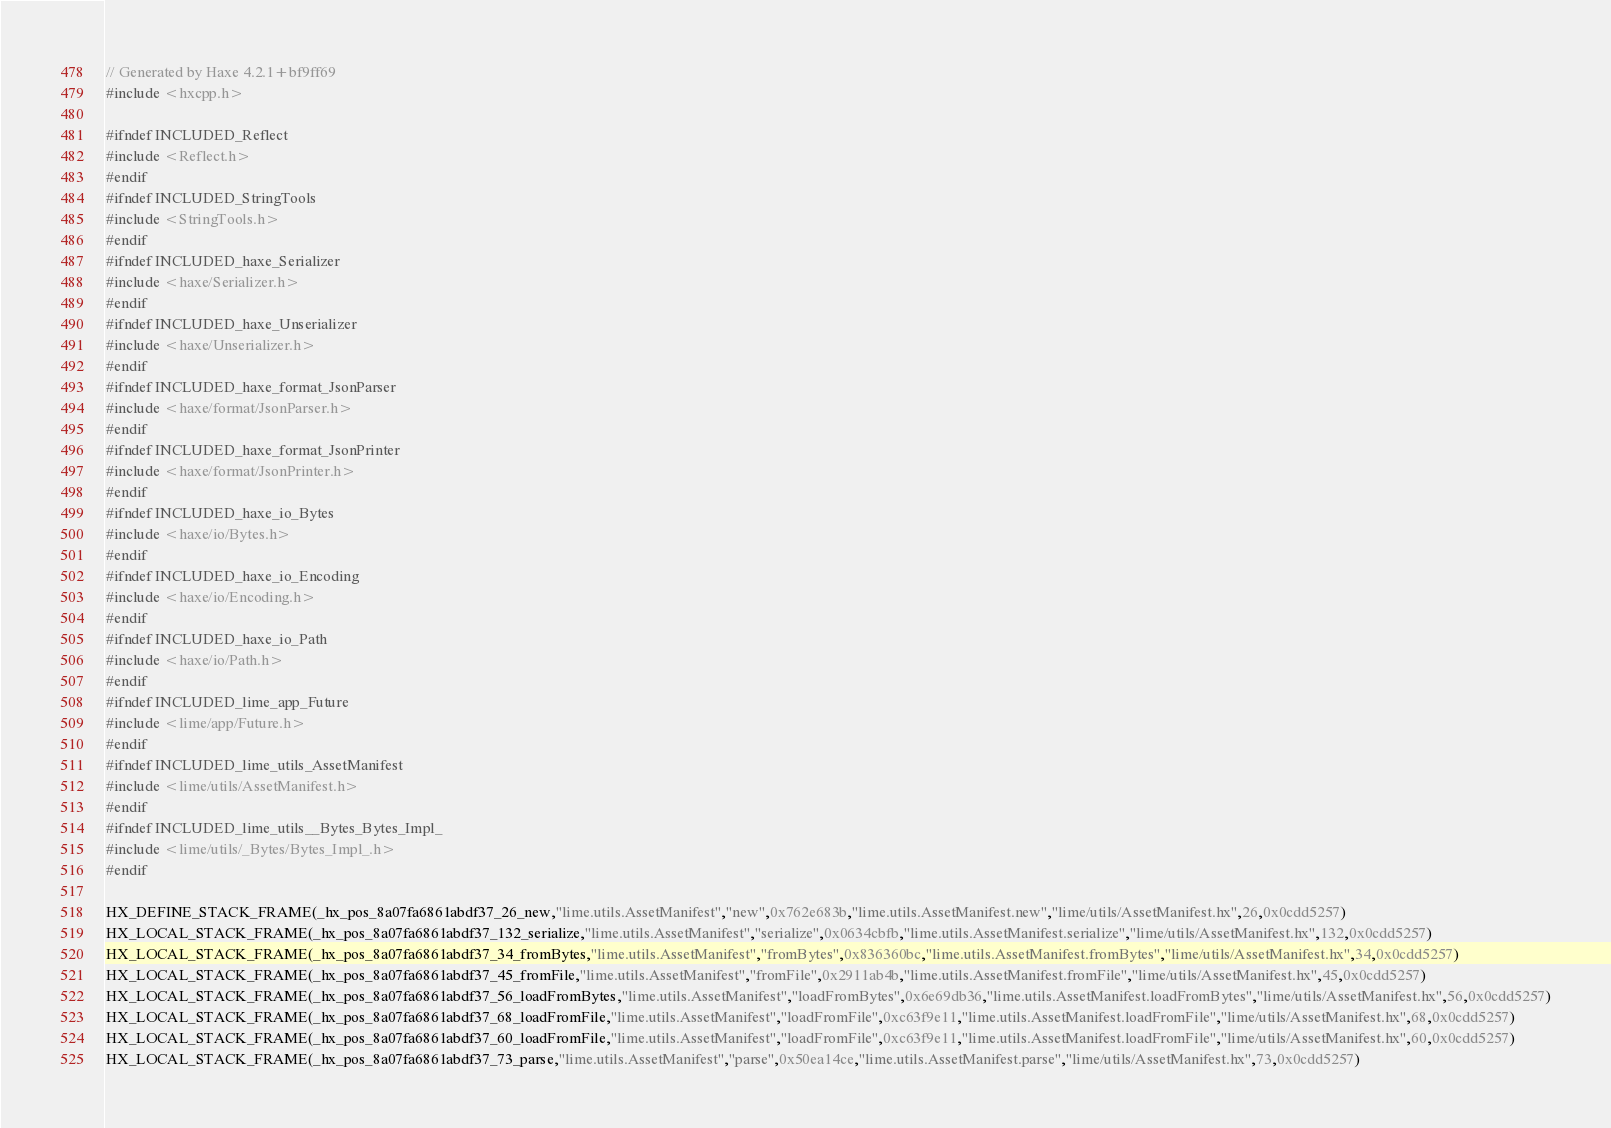Convert code to text. <code><loc_0><loc_0><loc_500><loc_500><_C++_>// Generated by Haxe 4.2.1+bf9ff69
#include <hxcpp.h>

#ifndef INCLUDED_Reflect
#include <Reflect.h>
#endif
#ifndef INCLUDED_StringTools
#include <StringTools.h>
#endif
#ifndef INCLUDED_haxe_Serializer
#include <haxe/Serializer.h>
#endif
#ifndef INCLUDED_haxe_Unserializer
#include <haxe/Unserializer.h>
#endif
#ifndef INCLUDED_haxe_format_JsonParser
#include <haxe/format/JsonParser.h>
#endif
#ifndef INCLUDED_haxe_format_JsonPrinter
#include <haxe/format/JsonPrinter.h>
#endif
#ifndef INCLUDED_haxe_io_Bytes
#include <haxe/io/Bytes.h>
#endif
#ifndef INCLUDED_haxe_io_Encoding
#include <haxe/io/Encoding.h>
#endif
#ifndef INCLUDED_haxe_io_Path
#include <haxe/io/Path.h>
#endif
#ifndef INCLUDED_lime_app_Future
#include <lime/app/Future.h>
#endif
#ifndef INCLUDED_lime_utils_AssetManifest
#include <lime/utils/AssetManifest.h>
#endif
#ifndef INCLUDED_lime_utils__Bytes_Bytes_Impl_
#include <lime/utils/_Bytes/Bytes_Impl_.h>
#endif

HX_DEFINE_STACK_FRAME(_hx_pos_8a07fa6861abdf37_26_new,"lime.utils.AssetManifest","new",0x762e683b,"lime.utils.AssetManifest.new","lime/utils/AssetManifest.hx",26,0x0cdd5257)
HX_LOCAL_STACK_FRAME(_hx_pos_8a07fa6861abdf37_132_serialize,"lime.utils.AssetManifest","serialize",0x0634cbfb,"lime.utils.AssetManifest.serialize","lime/utils/AssetManifest.hx",132,0x0cdd5257)
HX_LOCAL_STACK_FRAME(_hx_pos_8a07fa6861abdf37_34_fromBytes,"lime.utils.AssetManifest","fromBytes",0x836360bc,"lime.utils.AssetManifest.fromBytes","lime/utils/AssetManifest.hx",34,0x0cdd5257)
HX_LOCAL_STACK_FRAME(_hx_pos_8a07fa6861abdf37_45_fromFile,"lime.utils.AssetManifest","fromFile",0x2911ab4b,"lime.utils.AssetManifest.fromFile","lime/utils/AssetManifest.hx",45,0x0cdd5257)
HX_LOCAL_STACK_FRAME(_hx_pos_8a07fa6861abdf37_56_loadFromBytes,"lime.utils.AssetManifest","loadFromBytes",0x6e69db36,"lime.utils.AssetManifest.loadFromBytes","lime/utils/AssetManifest.hx",56,0x0cdd5257)
HX_LOCAL_STACK_FRAME(_hx_pos_8a07fa6861abdf37_68_loadFromFile,"lime.utils.AssetManifest","loadFromFile",0xc63f9e11,"lime.utils.AssetManifest.loadFromFile","lime/utils/AssetManifest.hx",68,0x0cdd5257)
HX_LOCAL_STACK_FRAME(_hx_pos_8a07fa6861abdf37_60_loadFromFile,"lime.utils.AssetManifest","loadFromFile",0xc63f9e11,"lime.utils.AssetManifest.loadFromFile","lime/utils/AssetManifest.hx",60,0x0cdd5257)
HX_LOCAL_STACK_FRAME(_hx_pos_8a07fa6861abdf37_73_parse,"lime.utils.AssetManifest","parse",0x50ea14ce,"lime.utils.AssetManifest.parse","lime/utils/AssetManifest.hx",73,0x0cdd5257)</code> 